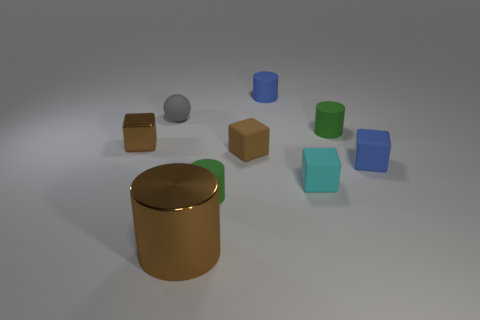Subtract all brown metal cubes. How many cubes are left? 3 Subtract all brown cubes. How many cubes are left? 2 Add 1 tiny brown rubber objects. How many objects exist? 10 Subtract all yellow cylinders. How many gray cubes are left? 0 Subtract all cylinders. How many objects are left? 5 Subtract 1 spheres. How many spheres are left? 0 Subtract all green spheres. Subtract all red blocks. How many spheres are left? 1 Subtract all large red cubes. Subtract all small cyan rubber cubes. How many objects are left? 8 Add 7 brown cylinders. How many brown cylinders are left? 8 Add 3 brown rubber blocks. How many brown rubber blocks exist? 4 